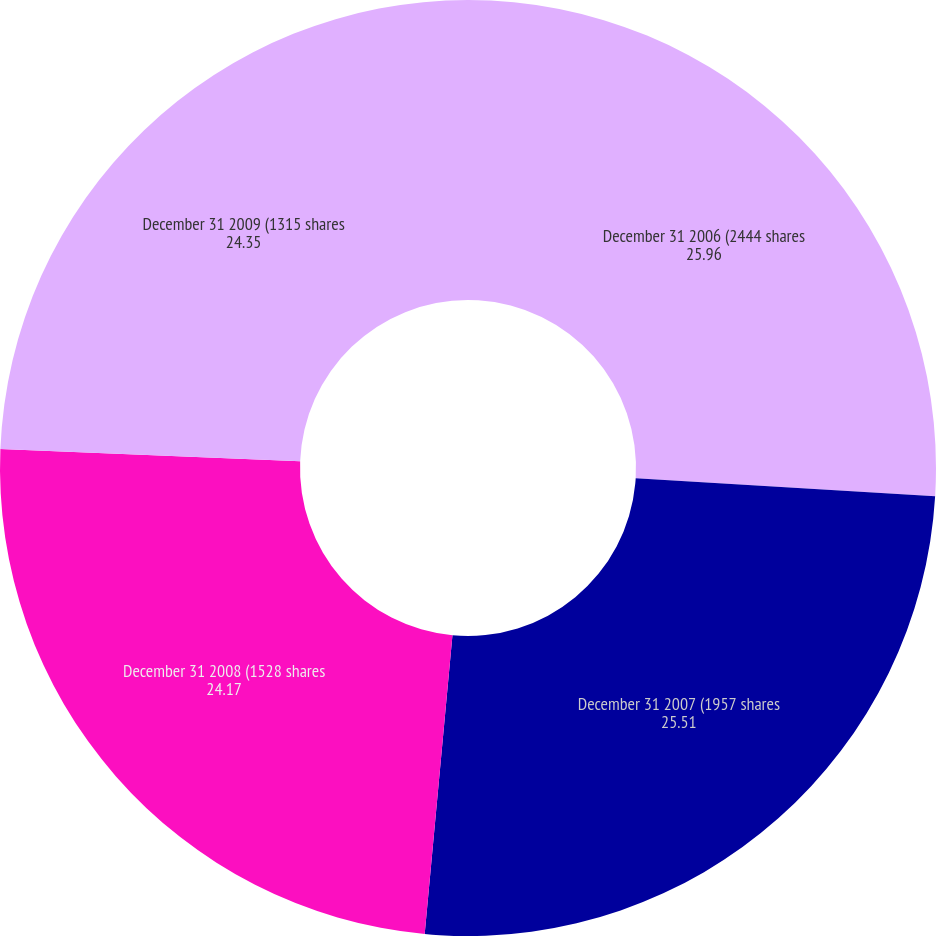Convert chart to OTSL. <chart><loc_0><loc_0><loc_500><loc_500><pie_chart><fcel>December 31 2006 (2444 shares<fcel>December 31 2007 (1957 shares<fcel>December 31 2008 (1528 shares<fcel>December 31 2009 (1315 shares<nl><fcel>25.96%<fcel>25.51%<fcel>24.17%<fcel>24.35%<nl></chart> 